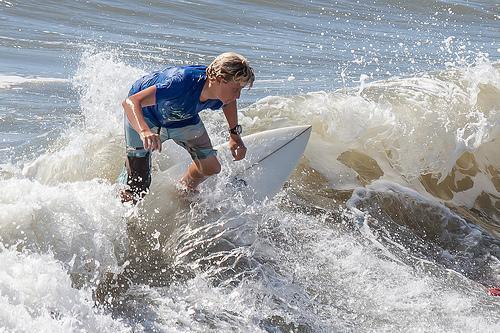How many women are there?
Give a very brief answer. 1. 